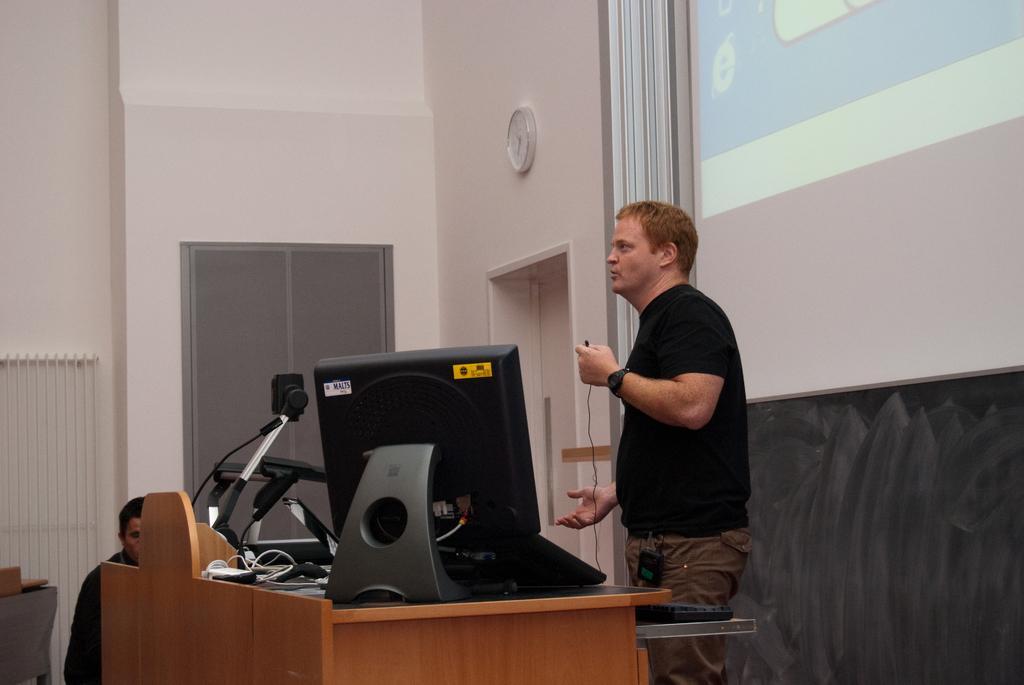Can you describe this image briefly? In this image in the center there is one person who is standing and he is holding a mike and talking, in front of him there is a table. On the table there is a computer, mike and some other objects. And on the left side there is another person, in the background there is a wall, window, door and on the wall there is one clock and on the right side there is a screen. 